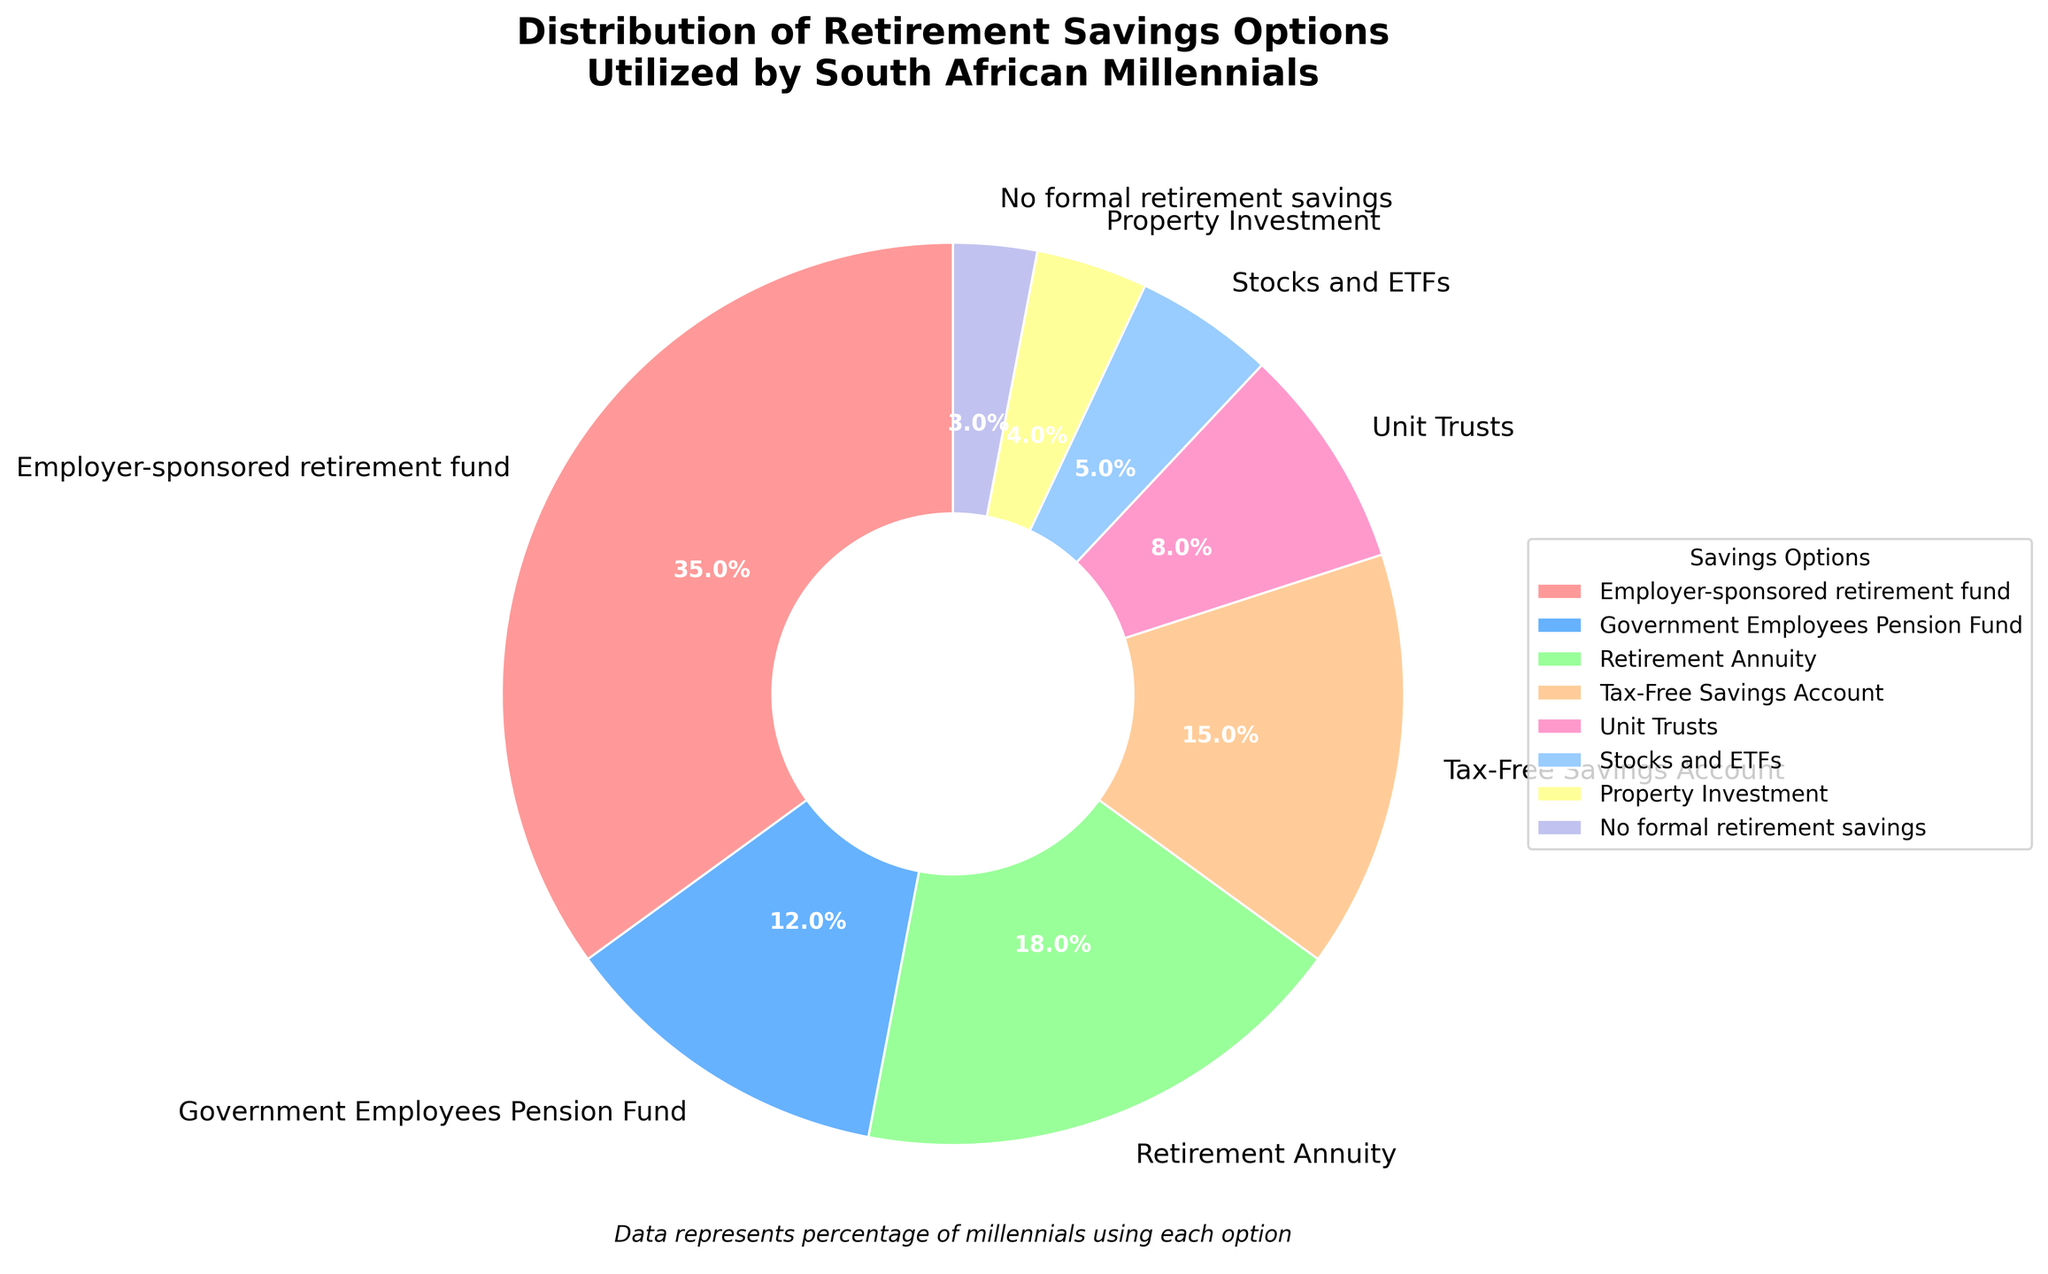what is the most popular retirement savings option according to the pie chart? The most popular retirement savings option can be identified by looking for the largest wedge in the pie chart. The largest wedge corresponds to "Employer-sponsored retirement fund", which occupies 35% of the pie chart.
Answer: Employer-sponsored retirement fund What percentage of South African millennials have no formal retirement savings? To find the percentage of millennials with no formal retirement savings, look for the segment labeled "No formal retirement savings" in the pie chart. It shows a percentage of 3%.
Answer: 3% Which retirement savings option is used more: Unit Trusts or Property Investment? Comparing the sizes of the wedges for "Unit Trusts" and "Property Investment" in the pie chart, the "Unit Trusts" wedge is larger with 8%, while "Property Investment" has 4%. Therefore, Unit Trusts is used more.
Answer: Unit Trusts What is the combined percentage of millennials using Retirement Annuities and Tax-Free Savings Accounts? To find the combined percentage, add the individual percentages of "Retirement Annuity" and "Tax-Free Savings Account". The figures are 18% and 15% respectively. Adding these values gives 18% + 15% = 33%.
Answer: 33% Which is used more by millennials: Government Employees Pension Fund or Stocks and ETFs? Comparing the wedges for "Government Employees Pension Fund" and "Stocks and ETFs" in the pie chart, "Government Employees Pension Fund" has 12%, while "Stocks and ETFs" has 5%. Therefore, Government Employees Pension Fund is used more.
Answer: Government Employees Pension Fund What is the percentage difference between those who use Employer-sponsored retirement funds and those who use Unit Trusts? To calculate the percentage difference, subtract the percentage of "Unit Trusts" from the percentage of "Employer-sponsored retirement fund". The figures are 35% and 8% respectively. The difference is 35% - 8% = 27%.
Answer: 27% Which category represents a smaller proportion: Stocks and ETFs or Property Investment? Comparing the wedges for "Stocks and ETFs" and "Property Investment" in the pie chart, "Stocks and ETFs" has 5% and "Property Investment" has 4%. Therefore, Property Investment represents a smaller proportion.
Answer: Property Investment What proportion of millennials use either Employer-sponsored retirement funds or Government Employees Pension Fund? To find the combined proportion, add the individual percentages of "Employer-sponsored retirement fund" and "Government Employees Pension Fund". The figures are 35% and 12% respectively. Adding these values gives 35% + 12% = 47%.
Answer: 47% Which segment has the second-highest percentage and what is the savings option? The second-largest wedge in the pie chart corresponds to "Retirement Annuity" with a percentage of 18%.
Answer: Retirement Annuity, 18% How many visual categories (different options) of retirement savings are depicted in the pie chart? Count the total number of distinct segments in the pie chart. The data lists 8 different options: Employer-sponsored retirement fund, Government Employees Pension Fund, Retirement Annuity, Tax-Free Savings Account, Unit Trusts, Stocks and ETFs, Property Investment, and No formal retirement savings.
Answer: 8 